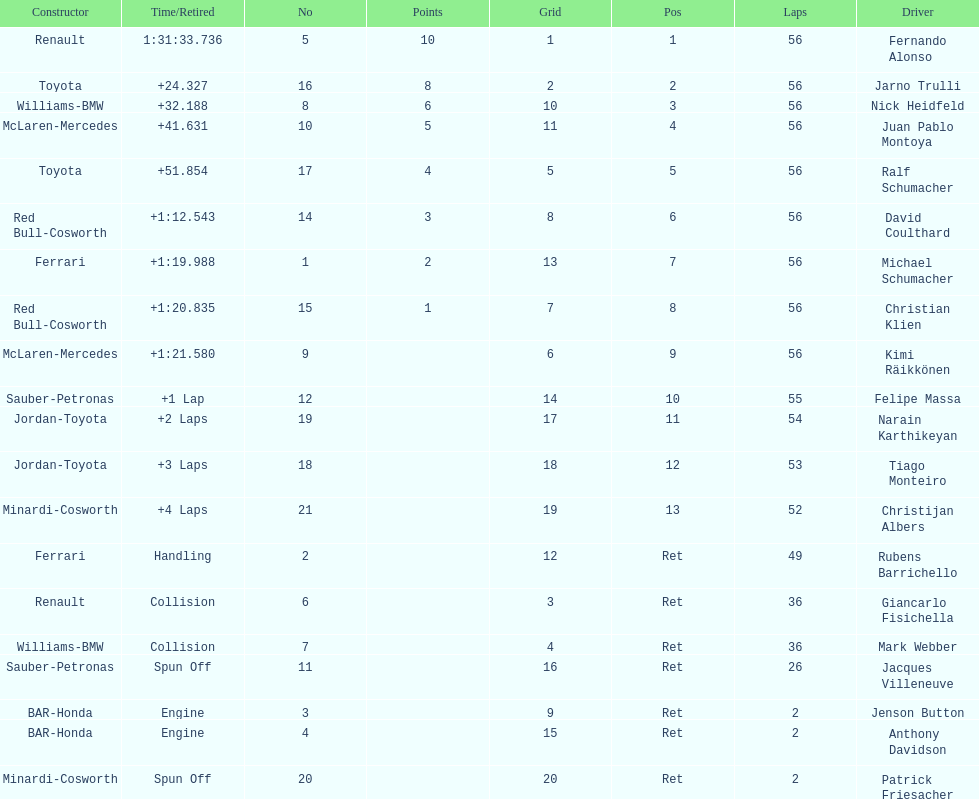How many bmws finished before webber? 1. 